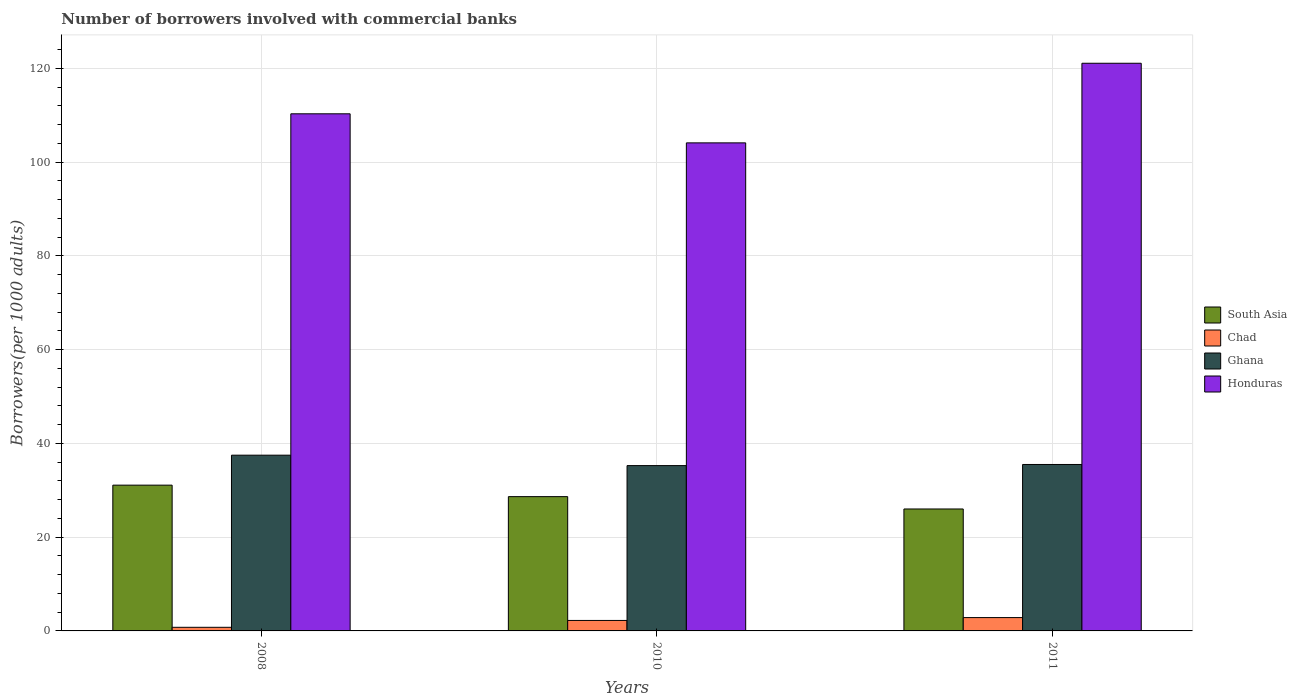How many groups of bars are there?
Provide a short and direct response. 3. How many bars are there on the 3rd tick from the right?
Offer a terse response. 4. What is the number of borrowers involved with commercial banks in Ghana in 2010?
Provide a short and direct response. 35.26. Across all years, what is the maximum number of borrowers involved with commercial banks in Honduras?
Your response must be concise. 121.07. Across all years, what is the minimum number of borrowers involved with commercial banks in South Asia?
Provide a short and direct response. 26.01. What is the total number of borrowers involved with commercial banks in South Asia in the graph?
Provide a short and direct response. 85.74. What is the difference between the number of borrowers involved with commercial banks in Chad in 2010 and that in 2011?
Ensure brevity in your answer.  -0.61. What is the difference between the number of borrowers involved with commercial banks in South Asia in 2008 and the number of borrowers involved with commercial banks in Ghana in 2011?
Give a very brief answer. -4.41. What is the average number of borrowers involved with commercial banks in Honduras per year?
Offer a very short reply. 111.82. In the year 2011, what is the difference between the number of borrowers involved with commercial banks in Honduras and number of borrowers involved with commercial banks in Ghana?
Provide a succinct answer. 85.57. In how many years, is the number of borrowers involved with commercial banks in Ghana greater than 88?
Keep it short and to the point. 0. What is the ratio of the number of borrowers involved with commercial banks in Ghana in 2008 to that in 2011?
Give a very brief answer. 1.06. Is the number of borrowers involved with commercial banks in Honduras in 2008 less than that in 2011?
Your answer should be compact. Yes. What is the difference between the highest and the second highest number of borrowers involved with commercial banks in Honduras?
Keep it short and to the point. 10.78. What is the difference between the highest and the lowest number of borrowers involved with commercial banks in Ghana?
Keep it short and to the point. 2.22. Is it the case that in every year, the sum of the number of borrowers involved with commercial banks in South Asia and number of borrowers involved with commercial banks in Chad is greater than the sum of number of borrowers involved with commercial banks in Ghana and number of borrowers involved with commercial banks in Honduras?
Ensure brevity in your answer.  No. What does the 4th bar from the left in 2010 represents?
Give a very brief answer. Honduras. What does the 1st bar from the right in 2008 represents?
Make the answer very short. Honduras. How many bars are there?
Provide a succinct answer. 12. Does the graph contain grids?
Offer a very short reply. Yes. Where does the legend appear in the graph?
Keep it short and to the point. Center right. How are the legend labels stacked?
Your answer should be compact. Vertical. What is the title of the graph?
Ensure brevity in your answer.  Number of borrowers involved with commercial banks. What is the label or title of the Y-axis?
Make the answer very short. Borrowers(per 1000 adults). What is the Borrowers(per 1000 adults) of South Asia in 2008?
Ensure brevity in your answer.  31.09. What is the Borrowers(per 1000 adults) of Chad in 2008?
Keep it short and to the point. 0.77. What is the Borrowers(per 1000 adults) of Ghana in 2008?
Make the answer very short. 37.48. What is the Borrowers(per 1000 adults) in Honduras in 2008?
Give a very brief answer. 110.29. What is the Borrowers(per 1000 adults) of South Asia in 2010?
Make the answer very short. 28.64. What is the Borrowers(per 1000 adults) of Chad in 2010?
Provide a succinct answer. 2.24. What is the Borrowers(per 1000 adults) in Ghana in 2010?
Make the answer very short. 35.26. What is the Borrowers(per 1000 adults) of Honduras in 2010?
Your answer should be compact. 104.09. What is the Borrowers(per 1000 adults) of South Asia in 2011?
Your answer should be compact. 26.01. What is the Borrowers(per 1000 adults) in Chad in 2011?
Offer a terse response. 2.84. What is the Borrowers(per 1000 adults) of Ghana in 2011?
Make the answer very short. 35.5. What is the Borrowers(per 1000 adults) in Honduras in 2011?
Offer a terse response. 121.07. Across all years, what is the maximum Borrowers(per 1000 adults) in South Asia?
Give a very brief answer. 31.09. Across all years, what is the maximum Borrowers(per 1000 adults) in Chad?
Make the answer very short. 2.84. Across all years, what is the maximum Borrowers(per 1000 adults) of Ghana?
Your answer should be very brief. 37.48. Across all years, what is the maximum Borrowers(per 1000 adults) in Honduras?
Your answer should be very brief. 121.07. Across all years, what is the minimum Borrowers(per 1000 adults) in South Asia?
Ensure brevity in your answer.  26.01. Across all years, what is the minimum Borrowers(per 1000 adults) of Chad?
Provide a succinct answer. 0.77. Across all years, what is the minimum Borrowers(per 1000 adults) of Ghana?
Ensure brevity in your answer.  35.26. Across all years, what is the minimum Borrowers(per 1000 adults) in Honduras?
Give a very brief answer. 104.09. What is the total Borrowers(per 1000 adults) in South Asia in the graph?
Provide a short and direct response. 85.74. What is the total Borrowers(per 1000 adults) in Chad in the graph?
Offer a very short reply. 5.85. What is the total Borrowers(per 1000 adults) of Ghana in the graph?
Keep it short and to the point. 108.24. What is the total Borrowers(per 1000 adults) of Honduras in the graph?
Your response must be concise. 335.46. What is the difference between the Borrowers(per 1000 adults) in South Asia in 2008 and that in 2010?
Offer a very short reply. 2.45. What is the difference between the Borrowers(per 1000 adults) of Chad in 2008 and that in 2010?
Give a very brief answer. -1.46. What is the difference between the Borrowers(per 1000 adults) of Ghana in 2008 and that in 2010?
Give a very brief answer. 2.22. What is the difference between the Borrowers(per 1000 adults) in Honduras in 2008 and that in 2010?
Give a very brief answer. 6.2. What is the difference between the Borrowers(per 1000 adults) in South Asia in 2008 and that in 2011?
Give a very brief answer. 5.08. What is the difference between the Borrowers(per 1000 adults) of Chad in 2008 and that in 2011?
Ensure brevity in your answer.  -2.07. What is the difference between the Borrowers(per 1000 adults) of Ghana in 2008 and that in 2011?
Offer a terse response. 1.98. What is the difference between the Borrowers(per 1000 adults) of Honduras in 2008 and that in 2011?
Your answer should be compact. -10.78. What is the difference between the Borrowers(per 1000 adults) in South Asia in 2010 and that in 2011?
Make the answer very short. 2.63. What is the difference between the Borrowers(per 1000 adults) in Chad in 2010 and that in 2011?
Your answer should be very brief. -0.61. What is the difference between the Borrowers(per 1000 adults) of Ghana in 2010 and that in 2011?
Offer a very short reply. -0.24. What is the difference between the Borrowers(per 1000 adults) in Honduras in 2010 and that in 2011?
Your answer should be very brief. -16.98. What is the difference between the Borrowers(per 1000 adults) of South Asia in 2008 and the Borrowers(per 1000 adults) of Chad in 2010?
Keep it short and to the point. 28.86. What is the difference between the Borrowers(per 1000 adults) of South Asia in 2008 and the Borrowers(per 1000 adults) of Ghana in 2010?
Ensure brevity in your answer.  -4.17. What is the difference between the Borrowers(per 1000 adults) in South Asia in 2008 and the Borrowers(per 1000 adults) in Honduras in 2010?
Provide a short and direct response. -73. What is the difference between the Borrowers(per 1000 adults) of Chad in 2008 and the Borrowers(per 1000 adults) of Ghana in 2010?
Ensure brevity in your answer.  -34.49. What is the difference between the Borrowers(per 1000 adults) in Chad in 2008 and the Borrowers(per 1000 adults) in Honduras in 2010?
Ensure brevity in your answer.  -103.32. What is the difference between the Borrowers(per 1000 adults) in Ghana in 2008 and the Borrowers(per 1000 adults) in Honduras in 2010?
Provide a succinct answer. -66.61. What is the difference between the Borrowers(per 1000 adults) in South Asia in 2008 and the Borrowers(per 1000 adults) in Chad in 2011?
Ensure brevity in your answer.  28.25. What is the difference between the Borrowers(per 1000 adults) in South Asia in 2008 and the Borrowers(per 1000 adults) in Ghana in 2011?
Provide a short and direct response. -4.41. What is the difference between the Borrowers(per 1000 adults) of South Asia in 2008 and the Borrowers(per 1000 adults) of Honduras in 2011?
Your response must be concise. -89.98. What is the difference between the Borrowers(per 1000 adults) of Chad in 2008 and the Borrowers(per 1000 adults) of Ghana in 2011?
Ensure brevity in your answer.  -34.73. What is the difference between the Borrowers(per 1000 adults) in Chad in 2008 and the Borrowers(per 1000 adults) in Honduras in 2011?
Provide a succinct answer. -120.3. What is the difference between the Borrowers(per 1000 adults) of Ghana in 2008 and the Borrowers(per 1000 adults) of Honduras in 2011?
Offer a very short reply. -83.59. What is the difference between the Borrowers(per 1000 adults) in South Asia in 2010 and the Borrowers(per 1000 adults) in Chad in 2011?
Your answer should be very brief. 25.8. What is the difference between the Borrowers(per 1000 adults) of South Asia in 2010 and the Borrowers(per 1000 adults) of Ghana in 2011?
Ensure brevity in your answer.  -6.86. What is the difference between the Borrowers(per 1000 adults) in South Asia in 2010 and the Borrowers(per 1000 adults) in Honduras in 2011?
Your answer should be compact. -92.43. What is the difference between the Borrowers(per 1000 adults) of Chad in 2010 and the Borrowers(per 1000 adults) of Ghana in 2011?
Your answer should be very brief. -33.26. What is the difference between the Borrowers(per 1000 adults) in Chad in 2010 and the Borrowers(per 1000 adults) in Honduras in 2011?
Keep it short and to the point. -118.84. What is the difference between the Borrowers(per 1000 adults) in Ghana in 2010 and the Borrowers(per 1000 adults) in Honduras in 2011?
Ensure brevity in your answer.  -85.81. What is the average Borrowers(per 1000 adults) in South Asia per year?
Your response must be concise. 28.58. What is the average Borrowers(per 1000 adults) in Chad per year?
Provide a short and direct response. 1.95. What is the average Borrowers(per 1000 adults) of Ghana per year?
Provide a short and direct response. 36.08. What is the average Borrowers(per 1000 adults) of Honduras per year?
Ensure brevity in your answer.  111.82. In the year 2008, what is the difference between the Borrowers(per 1000 adults) of South Asia and Borrowers(per 1000 adults) of Chad?
Offer a very short reply. 30.32. In the year 2008, what is the difference between the Borrowers(per 1000 adults) of South Asia and Borrowers(per 1000 adults) of Ghana?
Your answer should be compact. -6.39. In the year 2008, what is the difference between the Borrowers(per 1000 adults) in South Asia and Borrowers(per 1000 adults) in Honduras?
Offer a very short reply. -79.2. In the year 2008, what is the difference between the Borrowers(per 1000 adults) of Chad and Borrowers(per 1000 adults) of Ghana?
Ensure brevity in your answer.  -36.71. In the year 2008, what is the difference between the Borrowers(per 1000 adults) of Chad and Borrowers(per 1000 adults) of Honduras?
Keep it short and to the point. -109.52. In the year 2008, what is the difference between the Borrowers(per 1000 adults) of Ghana and Borrowers(per 1000 adults) of Honduras?
Ensure brevity in your answer.  -72.81. In the year 2010, what is the difference between the Borrowers(per 1000 adults) of South Asia and Borrowers(per 1000 adults) of Chad?
Your answer should be compact. 26.41. In the year 2010, what is the difference between the Borrowers(per 1000 adults) in South Asia and Borrowers(per 1000 adults) in Ghana?
Give a very brief answer. -6.62. In the year 2010, what is the difference between the Borrowers(per 1000 adults) in South Asia and Borrowers(per 1000 adults) in Honduras?
Your response must be concise. -75.45. In the year 2010, what is the difference between the Borrowers(per 1000 adults) in Chad and Borrowers(per 1000 adults) in Ghana?
Keep it short and to the point. -33.02. In the year 2010, what is the difference between the Borrowers(per 1000 adults) in Chad and Borrowers(per 1000 adults) in Honduras?
Your response must be concise. -101.86. In the year 2010, what is the difference between the Borrowers(per 1000 adults) of Ghana and Borrowers(per 1000 adults) of Honduras?
Keep it short and to the point. -68.83. In the year 2011, what is the difference between the Borrowers(per 1000 adults) in South Asia and Borrowers(per 1000 adults) in Chad?
Give a very brief answer. 23.17. In the year 2011, what is the difference between the Borrowers(per 1000 adults) of South Asia and Borrowers(per 1000 adults) of Ghana?
Provide a succinct answer. -9.49. In the year 2011, what is the difference between the Borrowers(per 1000 adults) of South Asia and Borrowers(per 1000 adults) of Honduras?
Offer a terse response. -95.06. In the year 2011, what is the difference between the Borrowers(per 1000 adults) of Chad and Borrowers(per 1000 adults) of Ghana?
Offer a terse response. -32.66. In the year 2011, what is the difference between the Borrowers(per 1000 adults) in Chad and Borrowers(per 1000 adults) in Honduras?
Ensure brevity in your answer.  -118.23. In the year 2011, what is the difference between the Borrowers(per 1000 adults) of Ghana and Borrowers(per 1000 adults) of Honduras?
Offer a terse response. -85.57. What is the ratio of the Borrowers(per 1000 adults) in South Asia in 2008 to that in 2010?
Offer a terse response. 1.09. What is the ratio of the Borrowers(per 1000 adults) in Chad in 2008 to that in 2010?
Keep it short and to the point. 0.35. What is the ratio of the Borrowers(per 1000 adults) in Ghana in 2008 to that in 2010?
Ensure brevity in your answer.  1.06. What is the ratio of the Borrowers(per 1000 adults) of Honduras in 2008 to that in 2010?
Your response must be concise. 1.06. What is the ratio of the Borrowers(per 1000 adults) of South Asia in 2008 to that in 2011?
Offer a very short reply. 1.2. What is the ratio of the Borrowers(per 1000 adults) of Chad in 2008 to that in 2011?
Ensure brevity in your answer.  0.27. What is the ratio of the Borrowers(per 1000 adults) in Ghana in 2008 to that in 2011?
Keep it short and to the point. 1.06. What is the ratio of the Borrowers(per 1000 adults) of Honduras in 2008 to that in 2011?
Keep it short and to the point. 0.91. What is the ratio of the Borrowers(per 1000 adults) of South Asia in 2010 to that in 2011?
Ensure brevity in your answer.  1.1. What is the ratio of the Borrowers(per 1000 adults) in Chad in 2010 to that in 2011?
Your answer should be compact. 0.79. What is the ratio of the Borrowers(per 1000 adults) in Honduras in 2010 to that in 2011?
Provide a succinct answer. 0.86. What is the difference between the highest and the second highest Borrowers(per 1000 adults) of South Asia?
Offer a terse response. 2.45. What is the difference between the highest and the second highest Borrowers(per 1000 adults) in Chad?
Offer a very short reply. 0.61. What is the difference between the highest and the second highest Borrowers(per 1000 adults) in Ghana?
Provide a short and direct response. 1.98. What is the difference between the highest and the second highest Borrowers(per 1000 adults) of Honduras?
Ensure brevity in your answer.  10.78. What is the difference between the highest and the lowest Borrowers(per 1000 adults) of South Asia?
Provide a short and direct response. 5.08. What is the difference between the highest and the lowest Borrowers(per 1000 adults) of Chad?
Offer a very short reply. 2.07. What is the difference between the highest and the lowest Borrowers(per 1000 adults) of Ghana?
Your response must be concise. 2.22. What is the difference between the highest and the lowest Borrowers(per 1000 adults) in Honduras?
Give a very brief answer. 16.98. 